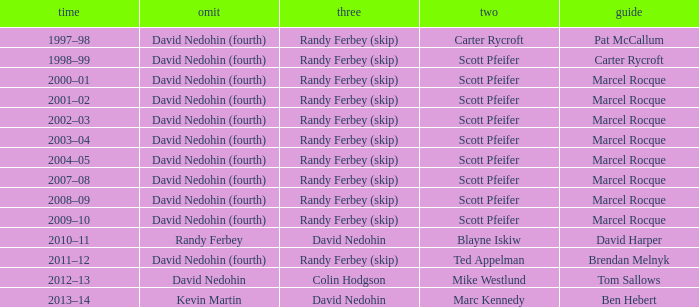Which Lead has a Third of randy ferbey (skip), a Second of scott pfeifer, and a Season of 2009–10? Marcel Rocque. 